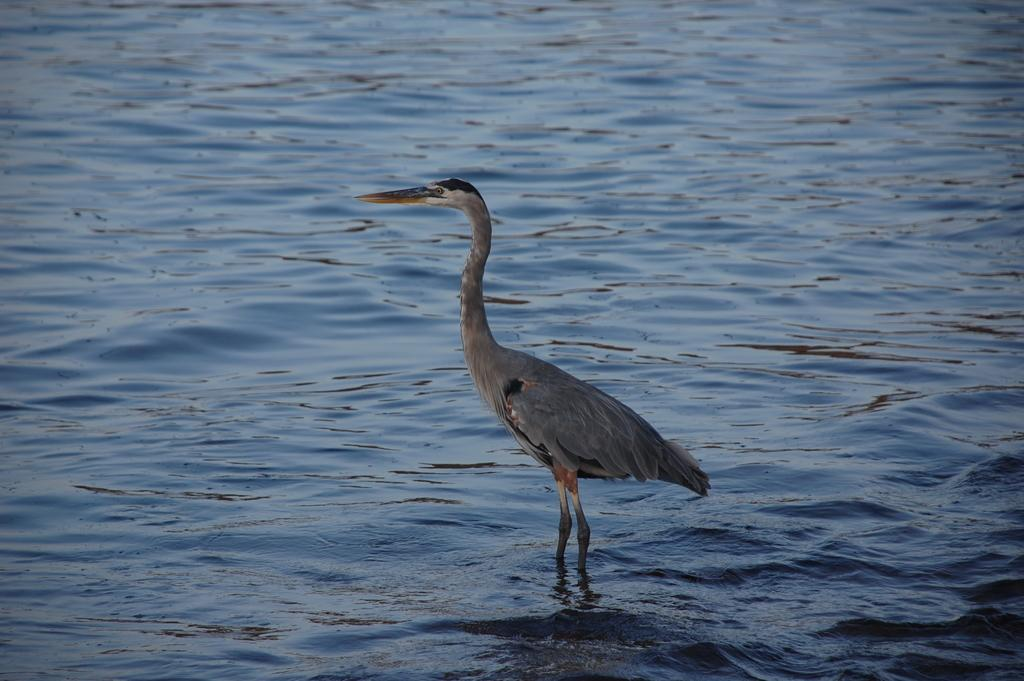What type of animal is in the image? There is a bird in the image. Where is the bird located in the image? The bird is standing in the water. What color is the bird in the image? The bird is gray in color. What color is the water in the image? The water is blue in color. What disease does the bird have in the image? There is no indication in the image that the bird has any disease. Who is the creator of the bird in the image? The image is a photograph or illustration, not a creation by an artist, so there is no creator of the bird in the image. 